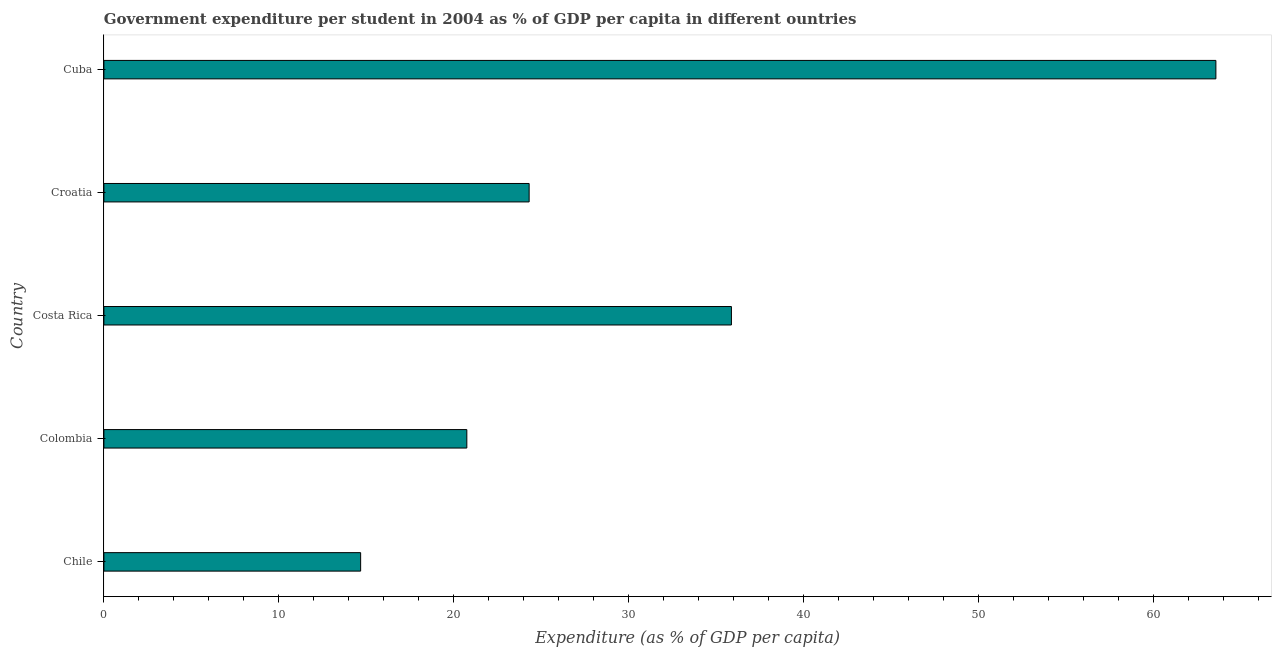Does the graph contain any zero values?
Your answer should be compact. No. What is the title of the graph?
Offer a very short reply. Government expenditure per student in 2004 as % of GDP per capita in different ountries. What is the label or title of the X-axis?
Your answer should be compact. Expenditure (as % of GDP per capita). What is the label or title of the Y-axis?
Give a very brief answer. Country. What is the government expenditure per student in Croatia?
Your answer should be compact. 24.31. Across all countries, what is the maximum government expenditure per student?
Ensure brevity in your answer.  63.58. Across all countries, what is the minimum government expenditure per student?
Your response must be concise. 14.68. In which country was the government expenditure per student maximum?
Your answer should be compact. Cuba. What is the sum of the government expenditure per student?
Keep it short and to the point. 159.21. What is the difference between the government expenditure per student in Colombia and Croatia?
Provide a short and direct response. -3.56. What is the average government expenditure per student per country?
Offer a very short reply. 31.84. What is the median government expenditure per student?
Ensure brevity in your answer.  24.31. In how many countries, is the government expenditure per student greater than 54 %?
Offer a very short reply. 1. What is the ratio of the government expenditure per student in Colombia to that in Cuba?
Your answer should be compact. 0.33. Is the government expenditure per student in Colombia less than that in Cuba?
Provide a succinct answer. Yes. What is the difference between the highest and the second highest government expenditure per student?
Ensure brevity in your answer.  27.7. What is the difference between the highest and the lowest government expenditure per student?
Provide a short and direct response. 48.9. In how many countries, is the government expenditure per student greater than the average government expenditure per student taken over all countries?
Your response must be concise. 2. How many bars are there?
Provide a succinct answer. 5. How many countries are there in the graph?
Your answer should be very brief. 5. What is the difference between two consecutive major ticks on the X-axis?
Provide a succinct answer. 10. What is the Expenditure (as % of GDP per capita) in Chile?
Your answer should be compact. 14.68. What is the Expenditure (as % of GDP per capita) in Colombia?
Your answer should be compact. 20.75. What is the Expenditure (as % of GDP per capita) in Costa Rica?
Provide a short and direct response. 35.88. What is the Expenditure (as % of GDP per capita) in Croatia?
Provide a short and direct response. 24.31. What is the Expenditure (as % of GDP per capita) in Cuba?
Your answer should be compact. 63.58. What is the difference between the Expenditure (as % of GDP per capita) in Chile and Colombia?
Ensure brevity in your answer.  -6.07. What is the difference between the Expenditure (as % of GDP per capita) in Chile and Costa Rica?
Your answer should be compact. -21.2. What is the difference between the Expenditure (as % of GDP per capita) in Chile and Croatia?
Make the answer very short. -9.63. What is the difference between the Expenditure (as % of GDP per capita) in Chile and Cuba?
Your answer should be compact. -48.9. What is the difference between the Expenditure (as % of GDP per capita) in Colombia and Costa Rica?
Provide a succinct answer. -15.13. What is the difference between the Expenditure (as % of GDP per capita) in Colombia and Croatia?
Your answer should be very brief. -3.56. What is the difference between the Expenditure (as % of GDP per capita) in Colombia and Cuba?
Keep it short and to the point. -42.83. What is the difference between the Expenditure (as % of GDP per capita) in Costa Rica and Croatia?
Keep it short and to the point. 11.57. What is the difference between the Expenditure (as % of GDP per capita) in Costa Rica and Cuba?
Your answer should be very brief. -27.7. What is the difference between the Expenditure (as % of GDP per capita) in Croatia and Cuba?
Provide a short and direct response. -39.27. What is the ratio of the Expenditure (as % of GDP per capita) in Chile to that in Colombia?
Offer a terse response. 0.71. What is the ratio of the Expenditure (as % of GDP per capita) in Chile to that in Costa Rica?
Ensure brevity in your answer.  0.41. What is the ratio of the Expenditure (as % of GDP per capita) in Chile to that in Croatia?
Ensure brevity in your answer.  0.6. What is the ratio of the Expenditure (as % of GDP per capita) in Chile to that in Cuba?
Ensure brevity in your answer.  0.23. What is the ratio of the Expenditure (as % of GDP per capita) in Colombia to that in Costa Rica?
Your answer should be very brief. 0.58. What is the ratio of the Expenditure (as % of GDP per capita) in Colombia to that in Croatia?
Provide a succinct answer. 0.85. What is the ratio of the Expenditure (as % of GDP per capita) in Colombia to that in Cuba?
Make the answer very short. 0.33. What is the ratio of the Expenditure (as % of GDP per capita) in Costa Rica to that in Croatia?
Your answer should be compact. 1.48. What is the ratio of the Expenditure (as % of GDP per capita) in Costa Rica to that in Cuba?
Offer a very short reply. 0.56. What is the ratio of the Expenditure (as % of GDP per capita) in Croatia to that in Cuba?
Your response must be concise. 0.38. 